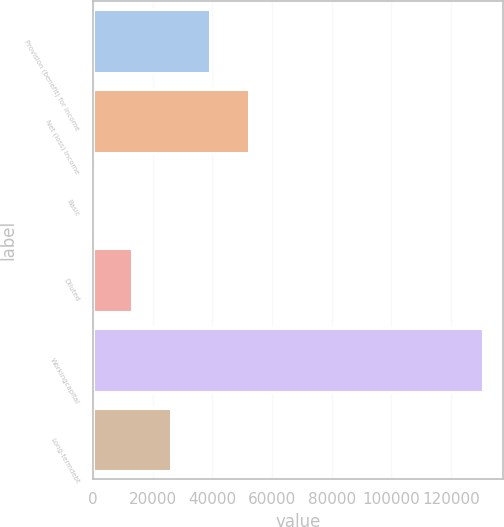<chart> <loc_0><loc_0><loc_500><loc_500><bar_chart><fcel>Provision (benefit) for income<fcel>Net (loss) income<fcel>Basic<fcel>Diluted<fcel>Workingcapital<fcel>Long-termdebt<nl><fcel>39239.8<fcel>52319.7<fcel>0.11<fcel>13080<fcel>130799<fcel>26159.9<nl></chart> 